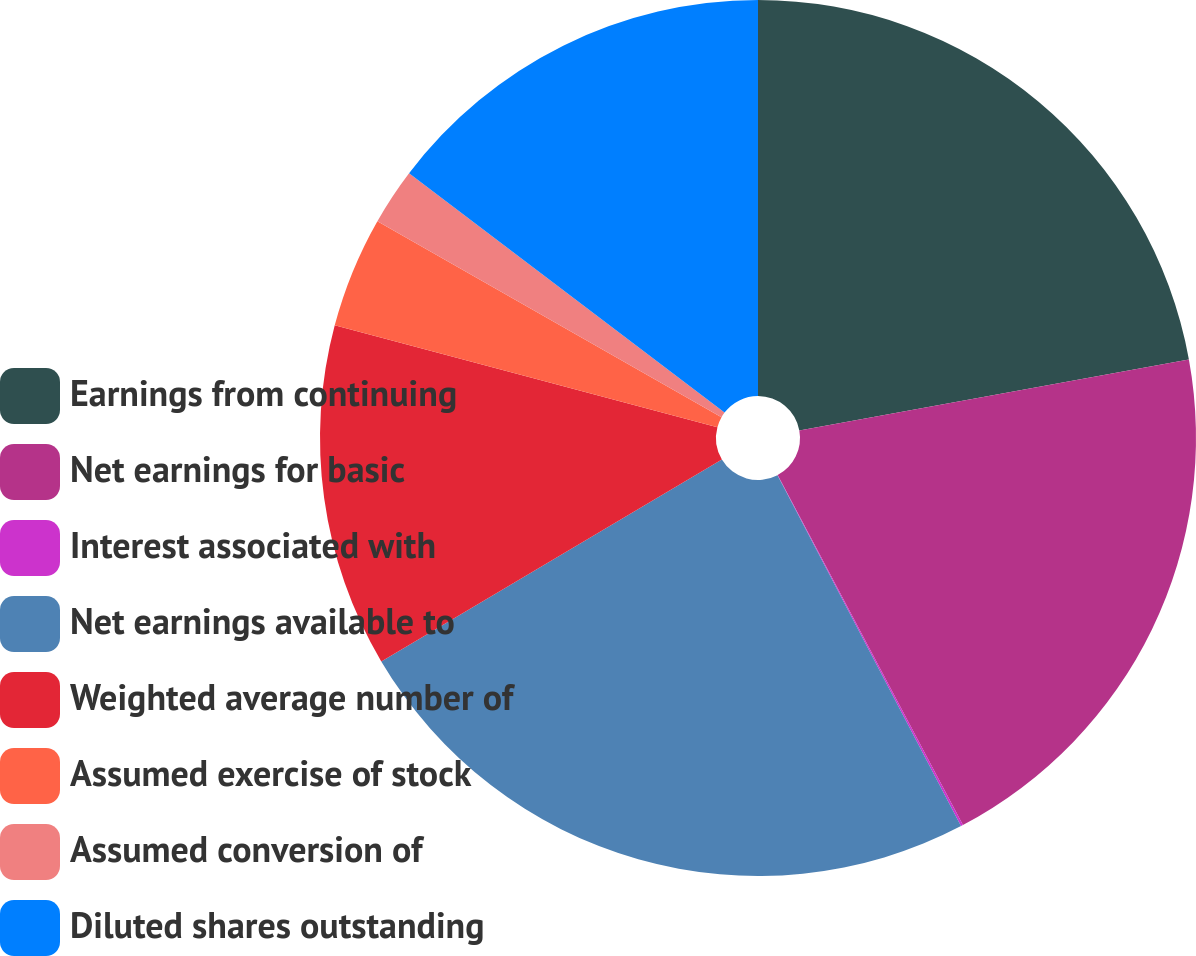Convert chart. <chart><loc_0><loc_0><loc_500><loc_500><pie_chart><fcel>Earnings from continuing<fcel>Net earnings for basic<fcel>Interest associated with<fcel>Net earnings available to<fcel>Weighted average number of<fcel>Assumed exercise of stock<fcel>Assumed conversion of<fcel>Diluted shares outstanding<nl><fcel>22.13%<fcel>20.12%<fcel>0.08%<fcel>24.15%<fcel>12.66%<fcel>4.1%<fcel>2.09%<fcel>14.67%<nl></chart> 